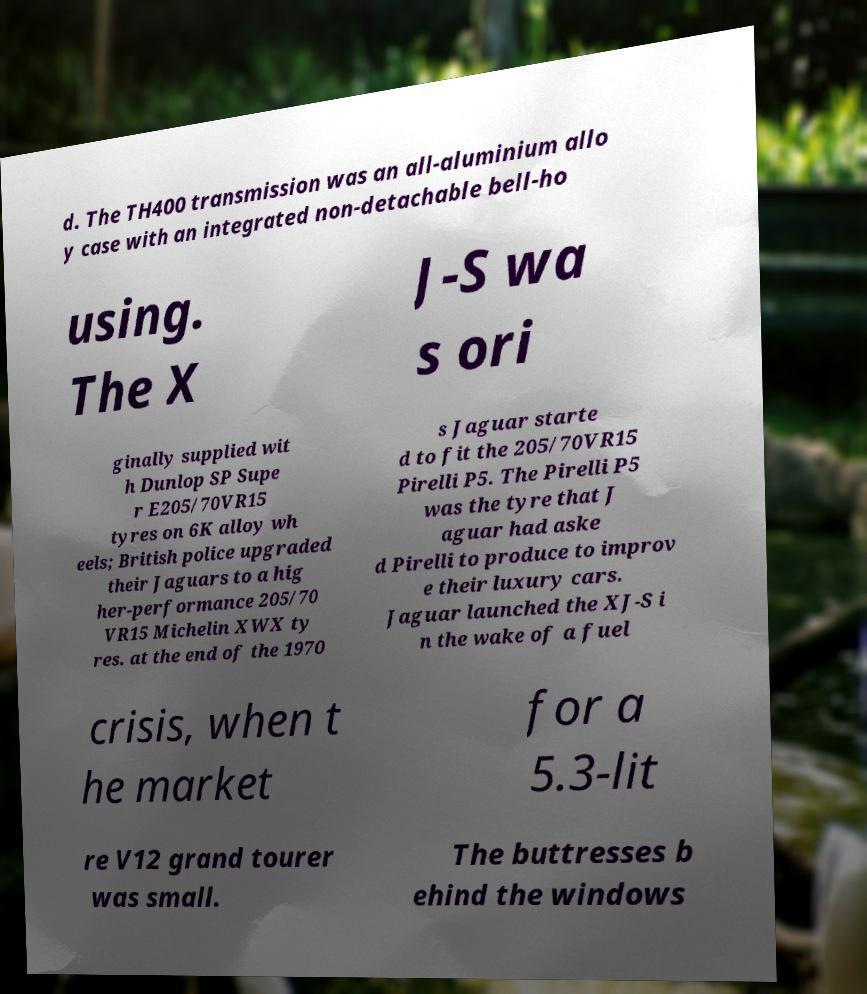I need the written content from this picture converted into text. Can you do that? d. The TH400 transmission was an all-aluminium allo y case with an integrated non-detachable bell-ho using. The X J-S wa s ori ginally supplied wit h Dunlop SP Supe r E205/70VR15 tyres on 6K alloy wh eels; British police upgraded their Jaguars to a hig her-performance 205/70 VR15 Michelin XWX ty res. at the end of the 1970 s Jaguar starte d to fit the 205/70VR15 Pirelli P5. The Pirelli P5 was the tyre that J aguar had aske d Pirelli to produce to improv e their luxury cars. Jaguar launched the XJ-S i n the wake of a fuel crisis, when t he market for a 5.3-lit re V12 grand tourer was small. The buttresses b ehind the windows 